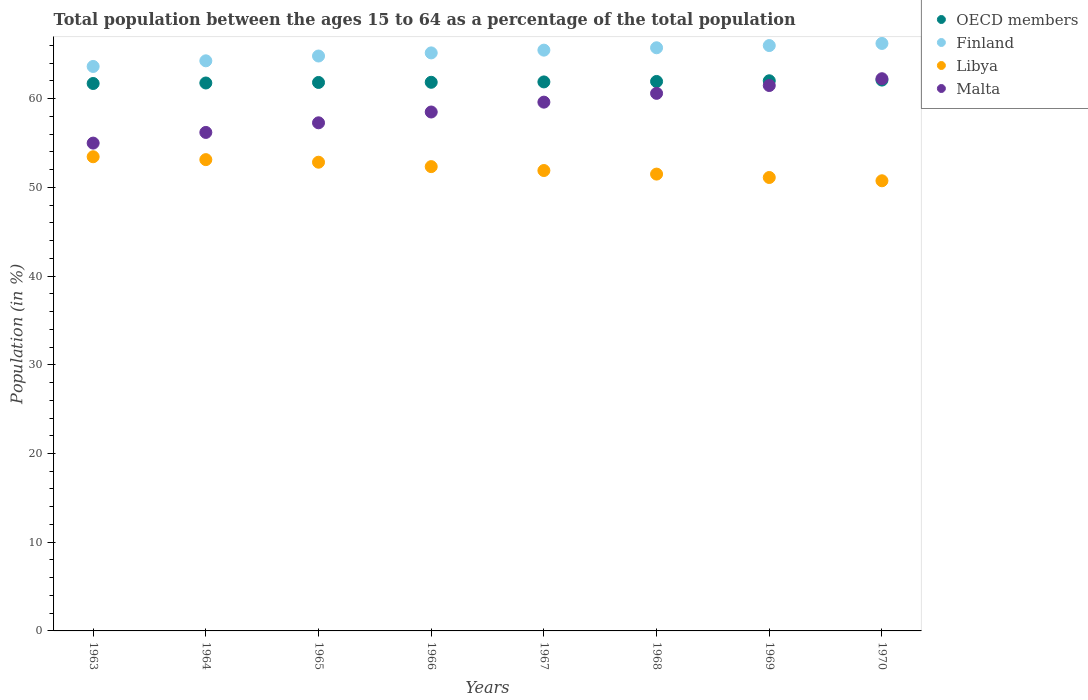Is the number of dotlines equal to the number of legend labels?
Offer a terse response. Yes. What is the percentage of the population ages 15 to 64 in Libya in 1968?
Keep it short and to the point. 51.5. Across all years, what is the maximum percentage of the population ages 15 to 64 in Finland?
Ensure brevity in your answer.  66.22. Across all years, what is the minimum percentage of the population ages 15 to 64 in Finland?
Provide a short and direct response. 63.63. In which year was the percentage of the population ages 15 to 64 in Libya minimum?
Make the answer very short. 1970. What is the total percentage of the population ages 15 to 64 in Libya in the graph?
Give a very brief answer. 417. What is the difference between the percentage of the population ages 15 to 64 in Libya in 1967 and that in 1970?
Keep it short and to the point. 1.16. What is the difference between the percentage of the population ages 15 to 64 in Libya in 1969 and the percentage of the population ages 15 to 64 in Finland in 1966?
Offer a very short reply. -14.05. What is the average percentage of the population ages 15 to 64 in OECD members per year?
Your answer should be compact. 61.88. In the year 1964, what is the difference between the percentage of the population ages 15 to 64 in Malta and percentage of the population ages 15 to 64 in Libya?
Your response must be concise. 3.07. In how many years, is the percentage of the population ages 15 to 64 in Finland greater than 38?
Provide a succinct answer. 8. What is the ratio of the percentage of the population ages 15 to 64 in Finland in 1964 to that in 1970?
Keep it short and to the point. 0.97. Is the difference between the percentage of the population ages 15 to 64 in Malta in 1963 and 1964 greater than the difference between the percentage of the population ages 15 to 64 in Libya in 1963 and 1964?
Give a very brief answer. No. What is the difference between the highest and the second highest percentage of the population ages 15 to 64 in Finland?
Ensure brevity in your answer.  0.24. What is the difference between the highest and the lowest percentage of the population ages 15 to 64 in Finland?
Give a very brief answer. 2.59. In how many years, is the percentage of the population ages 15 to 64 in Libya greater than the average percentage of the population ages 15 to 64 in Libya taken over all years?
Provide a short and direct response. 4. Is it the case that in every year, the sum of the percentage of the population ages 15 to 64 in OECD members and percentage of the population ages 15 to 64 in Libya  is greater than the sum of percentage of the population ages 15 to 64 in Malta and percentage of the population ages 15 to 64 in Finland?
Ensure brevity in your answer.  Yes. Does the percentage of the population ages 15 to 64 in Libya monotonically increase over the years?
Your answer should be compact. No. Is the percentage of the population ages 15 to 64 in Finland strictly greater than the percentage of the population ages 15 to 64 in Malta over the years?
Make the answer very short. Yes. How many dotlines are there?
Offer a terse response. 4. What is the difference between two consecutive major ticks on the Y-axis?
Ensure brevity in your answer.  10. Does the graph contain any zero values?
Ensure brevity in your answer.  No. Does the graph contain grids?
Provide a succinct answer. No. Where does the legend appear in the graph?
Offer a very short reply. Top right. How many legend labels are there?
Your answer should be very brief. 4. What is the title of the graph?
Your answer should be compact. Total population between the ages 15 to 64 as a percentage of the total population. What is the label or title of the X-axis?
Ensure brevity in your answer.  Years. What is the label or title of the Y-axis?
Ensure brevity in your answer.  Population (in %). What is the Population (in %) in OECD members in 1963?
Your response must be concise. 61.71. What is the Population (in %) in Finland in 1963?
Your answer should be compact. 63.63. What is the Population (in %) in Libya in 1963?
Keep it short and to the point. 53.45. What is the Population (in %) in Malta in 1963?
Offer a terse response. 54.99. What is the Population (in %) in OECD members in 1964?
Offer a terse response. 61.76. What is the Population (in %) of Finland in 1964?
Keep it short and to the point. 64.26. What is the Population (in %) of Libya in 1964?
Your answer should be compact. 53.13. What is the Population (in %) of Malta in 1964?
Offer a very short reply. 56.19. What is the Population (in %) of OECD members in 1965?
Your answer should be very brief. 61.83. What is the Population (in %) of Finland in 1965?
Your response must be concise. 64.8. What is the Population (in %) of Libya in 1965?
Give a very brief answer. 52.84. What is the Population (in %) of Malta in 1965?
Offer a very short reply. 57.28. What is the Population (in %) in OECD members in 1966?
Keep it short and to the point. 61.84. What is the Population (in %) of Finland in 1966?
Make the answer very short. 65.16. What is the Population (in %) in Libya in 1966?
Keep it short and to the point. 52.34. What is the Population (in %) of Malta in 1966?
Your answer should be compact. 58.49. What is the Population (in %) of OECD members in 1967?
Offer a terse response. 61.89. What is the Population (in %) in Finland in 1967?
Offer a very short reply. 65.47. What is the Population (in %) of Libya in 1967?
Make the answer very short. 51.9. What is the Population (in %) in Malta in 1967?
Make the answer very short. 59.6. What is the Population (in %) of OECD members in 1968?
Offer a very short reply. 61.94. What is the Population (in %) in Finland in 1968?
Offer a very short reply. 65.74. What is the Population (in %) in Libya in 1968?
Provide a short and direct response. 51.5. What is the Population (in %) in Malta in 1968?
Your response must be concise. 60.6. What is the Population (in %) in OECD members in 1969?
Provide a succinct answer. 62.01. What is the Population (in %) of Finland in 1969?
Give a very brief answer. 65.98. What is the Population (in %) of Libya in 1969?
Offer a terse response. 51.11. What is the Population (in %) in Malta in 1969?
Your answer should be compact. 61.48. What is the Population (in %) of OECD members in 1970?
Make the answer very short. 62.09. What is the Population (in %) of Finland in 1970?
Make the answer very short. 66.22. What is the Population (in %) of Libya in 1970?
Your response must be concise. 50.74. What is the Population (in %) of Malta in 1970?
Your answer should be very brief. 62.25. Across all years, what is the maximum Population (in %) in OECD members?
Ensure brevity in your answer.  62.09. Across all years, what is the maximum Population (in %) of Finland?
Your answer should be compact. 66.22. Across all years, what is the maximum Population (in %) of Libya?
Offer a terse response. 53.45. Across all years, what is the maximum Population (in %) of Malta?
Your response must be concise. 62.25. Across all years, what is the minimum Population (in %) in OECD members?
Offer a very short reply. 61.71. Across all years, what is the minimum Population (in %) in Finland?
Provide a short and direct response. 63.63. Across all years, what is the minimum Population (in %) of Libya?
Provide a succinct answer. 50.74. Across all years, what is the minimum Population (in %) in Malta?
Your answer should be very brief. 54.99. What is the total Population (in %) of OECD members in the graph?
Your answer should be compact. 495.07. What is the total Population (in %) of Finland in the graph?
Offer a very short reply. 521.26. What is the total Population (in %) of Libya in the graph?
Provide a succinct answer. 417. What is the total Population (in %) in Malta in the graph?
Ensure brevity in your answer.  470.88. What is the difference between the Population (in %) in OECD members in 1963 and that in 1964?
Offer a terse response. -0.06. What is the difference between the Population (in %) in Finland in 1963 and that in 1964?
Provide a succinct answer. -0.64. What is the difference between the Population (in %) in Libya in 1963 and that in 1964?
Your answer should be compact. 0.32. What is the difference between the Population (in %) of Malta in 1963 and that in 1964?
Offer a very short reply. -1.2. What is the difference between the Population (in %) of OECD members in 1963 and that in 1965?
Your answer should be compact. -0.12. What is the difference between the Population (in %) of Finland in 1963 and that in 1965?
Give a very brief answer. -1.18. What is the difference between the Population (in %) in Libya in 1963 and that in 1965?
Your answer should be compact. 0.61. What is the difference between the Population (in %) in Malta in 1963 and that in 1965?
Keep it short and to the point. -2.29. What is the difference between the Population (in %) in OECD members in 1963 and that in 1966?
Give a very brief answer. -0.14. What is the difference between the Population (in %) in Finland in 1963 and that in 1966?
Your answer should be compact. -1.53. What is the difference between the Population (in %) in Libya in 1963 and that in 1966?
Offer a terse response. 1.11. What is the difference between the Population (in %) of Malta in 1963 and that in 1966?
Offer a terse response. -3.51. What is the difference between the Population (in %) in OECD members in 1963 and that in 1967?
Your response must be concise. -0.18. What is the difference between the Population (in %) in Finland in 1963 and that in 1967?
Provide a short and direct response. -1.84. What is the difference between the Population (in %) in Libya in 1963 and that in 1967?
Give a very brief answer. 1.55. What is the difference between the Population (in %) of Malta in 1963 and that in 1967?
Provide a short and direct response. -4.62. What is the difference between the Population (in %) of OECD members in 1963 and that in 1968?
Give a very brief answer. -0.23. What is the difference between the Population (in %) in Finland in 1963 and that in 1968?
Make the answer very short. -2.11. What is the difference between the Population (in %) of Libya in 1963 and that in 1968?
Your response must be concise. 1.95. What is the difference between the Population (in %) of Malta in 1963 and that in 1968?
Make the answer very short. -5.61. What is the difference between the Population (in %) of OECD members in 1963 and that in 1969?
Make the answer very short. -0.31. What is the difference between the Population (in %) in Finland in 1963 and that in 1969?
Your response must be concise. -2.36. What is the difference between the Population (in %) in Libya in 1963 and that in 1969?
Your answer should be compact. 2.34. What is the difference between the Population (in %) in Malta in 1963 and that in 1969?
Keep it short and to the point. -6.49. What is the difference between the Population (in %) of OECD members in 1963 and that in 1970?
Your response must be concise. -0.39. What is the difference between the Population (in %) in Finland in 1963 and that in 1970?
Ensure brevity in your answer.  -2.59. What is the difference between the Population (in %) of Libya in 1963 and that in 1970?
Keep it short and to the point. 2.71. What is the difference between the Population (in %) of Malta in 1963 and that in 1970?
Provide a short and direct response. -7.26. What is the difference between the Population (in %) of OECD members in 1964 and that in 1965?
Ensure brevity in your answer.  -0.06. What is the difference between the Population (in %) of Finland in 1964 and that in 1965?
Keep it short and to the point. -0.54. What is the difference between the Population (in %) of Libya in 1964 and that in 1965?
Offer a terse response. 0.29. What is the difference between the Population (in %) in Malta in 1964 and that in 1965?
Offer a terse response. -1.08. What is the difference between the Population (in %) in OECD members in 1964 and that in 1966?
Your answer should be compact. -0.08. What is the difference between the Population (in %) of Finland in 1964 and that in 1966?
Offer a terse response. -0.89. What is the difference between the Population (in %) of Libya in 1964 and that in 1966?
Provide a short and direct response. 0.79. What is the difference between the Population (in %) of Malta in 1964 and that in 1966?
Offer a very short reply. -2.3. What is the difference between the Population (in %) in OECD members in 1964 and that in 1967?
Your response must be concise. -0.12. What is the difference between the Population (in %) of Finland in 1964 and that in 1967?
Make the answer very short. -1.2. What is the difference between the Population (in %) in Libya in 1964 and that in 1967?
Provide a succinct answer. 1.23. What is the difference between the Population (in %) of Malta in 1964 and that in 1967?
Make the answer very short. -3.41. What is the difference between the Population (in %) of OECD members in 1964 and that in 1968?
Offer a very short reply. -0.17. What is the difference between the Population (in %) in Finland in 1964 and that in 1968?
Offer a very short reply. -1.47. What is the difference between the Population (in %) in Libya in 1964 and that in 1968?
Offer a terse response. 1.63. What is the difference between the Population (in %) in Malta in 1964 and that in 1968?
Your answer should be very brief. -4.41. What is the difference between the Population (in %) in OECD members in 1964 and that in 1969?
Your answer should be compact. -0.25. What is the difference between the Population (in %) of Finland in 1964 and that in 1969?
Provide a short and direct response. -1.72. What is the difference between the Population (in %) in Libya in 1964 and that in 1969?
Provide a succinct answer. 2.01. What is the difference between the Population (in %) of Malta in 1964 and that in 1969?
Make the answer very short. -5.29. What is the difference between the Population (in %) of OECD members in 1964 and that in 1970?
Offer a very short reply. -0.33. What is the difference between the Population (in %) in Finland in 1964 and that in 1970?
Ensure brevity in your answer.  -1.96. What is the difference between the Population (in %) in Libya in 1964 and that in 1970?
Your answer should be very brief. 2.38. What is the difference between the Population (in %) in Malta in 1964 and that in 1970?
Make the answer very short. -6.05. What is the difference between the Population (in %) in OECD members in 1965 and that in 1966?
Provide a succinct answer. -0.02. What is the difference between the Population (in %) of Finland in 1965 and that in 1966?
Your answer should be very brief. -0.35. What is the difference between the Population (in %) in Libya in 1965 and that in 1966?
Provide a succinct answer. 0.5. What is the difference between the Population (in %) in Malta in 1965 and that in 1966?
Your answer should be compact. -1.22. What is the difference between the Population (in %) of OECD members in 1965 and that in 1967?
Keep it short and to the point. -0.06. What is the difference between the Population (in %) in Finland in 1965 and that in 1967?
Provide a short and direct response. -0.66. What is the difference between the Population (in %) in Libya in 1965 and that in 1967?
Ensure brevity in your answer.  0.94. What is the difference between the Population (in %) of Malta in 1965 and that in 1967?
Provide a short and direct response. -2.33. What is the difference between the Population (in %) of OECD members in 1965 and that in 1968?
Provide a short and direct response. -0.11. What is the difference between the Population (in %) in Finland in 1965 and that in 1968?
Ensure brevity in your answer.  -0.93. What is the difference between the Population (in %) in Libya in 1965 and that in 1968?
Keep it short and to the point. 1.34. What is the difference between the Population (in %) of Malta in 1965 and that in 1968?
Give a very brief answer. -3.32. What is the difference between the Population (in %) in OECD members in 1965 and that in 1969?
Provide a short and direct response. -0.19. What is the difference between the Population (in %) in Finland in 1965 and that in 1969?
Provide a short and direct response. -1.18. What is the difference between the Population (in %) in Libya in 1965 and that in 1969?
Provide a succinct answer. 1.72. What is the difference between the Population (in %) of Malta in 1965 and that in 1969?
Offer a very short reply. -4.2. What is the difference between the Population (in %) of OECD members in 1965 and that in 1970?
Keep it short and to the point. -0.27. What is the difference between the Population (in %) in Finland in 1965 and that in 1970?
Your answer should be very brief. -1.42. What is the difference between the Population (in %) in Libya in 1965 and that in 1970?
Offer a very short reply. 2.09. What is the difference between the Population (in %) in Malta in 1965 and that in 1970?
Provide a short and direct response. -4.97. What is the difference between the Population (in %) in OECD members in 1966 and that in 1967?
Your response must be concise. -0.04. What is the difference between the Population (in %) of Finland in 1966 and that in 1967?
Offer a terse response. -0.31. What is the difference between the Population (in %) of Libya in 1966 and that in 1967?
Offer a terse response. 0.44. What is the difference between the Population (in %) of Malta in 1966 and that in 1967?
Your answer should be compact. -1.11. What is the difference between the Population (in %) of OECD members in 1966 and that in 1968?
Your response must be concise. -0.09. What is the difference between the Population (in %) in Finland in 1966 and that in 1968?
Offer a very short reply. -0.58. What is the difference between the Population (in %) of Libya in 1966 and that in 1968?
Make the answer very short. 0.84. What is the difference between the Population (in %) of Malta in 1966 and that in 1968?
Offer a terse response. -2.1. What is the difference between the Population (in %) in OECD members in 1966 and that in 1969?
Your answer should be very brief. -0.17. What is the difference between the Population (in %) of Finland in 1966 and that in 1969?
Provide a succinct answer. -0.83. What is the difference between the Population (in %) in Libya in 1966 and that in 1969?
Give a very brief answer. 1.23. What is the difference between the Population (in %) of Malta in 1966 and that in 1969?
Ensure brevity in your answer.  -2.99. What is the difference between the Population (in %) in OECD members in 1966 and that in 1970?
Your answer should be compact. -0.25. What is the difference between the Population (in %) of Finland in 1966 and that in 1970?
Make the answer very short. -1.07. What is the difference between the Population (in %) of Libya in 1966 and that in 1970?
Offer a very short reply. 1.6. What is the difference between the Population (in %) of Malta in 1966 and that in 1970?
Your answer should be very brief. -3.75. What is the difference between the Population (in %) in OECD members in 1967 and that in 1968?
Keep it short and to the point. -0.05. What is the difference between the Population (in %) in Finland in 1967 and that in 1968?
Your answer should be very brief. -0.27. What is the difference between the Population (in %) in Libya in 1967 and that in 1968?
Ensure brevity in your answer.  0.4. What is the difference between the Population (in %) in Malta in 1967 and that in 1968?
Your answer should be very brief. -0.99. What is the difference between the Population (in %) in OECD members in 1967 and that in 1969?
Provide a succinct answer. -0.13. What is the difference between the Population (in %) in Finland in 1967 and that in 1969?
Ensure brevity in your answer.  -0.52. What is the difference between the Population (in %) in Libya in 1967 and that in 1969?
Provide a short and direct response. 0.79. What is the difference between the Population (in %) in Malta in 1967 and that in 1969?
Ensure brevity in your answer.  -1.88. What is the difference between the Population (in %) of OECD members in 1967 and that in 1970?
Make the answer very short. -0.21. What is the difference between the Population (in %) in Finland in 1967 and that in 1970?
Your response must be concise. -0.76. What is the difference between the Population (in %) of Libya in 1967 and that in 1970?
Keep it short and to the point. 1.16. What is the difference between the Population (in %) in Malta in 1967 and that in 1970?
Give a very brief answer. -2.64. What is the difference between the Population (in %) in OECD members in 1968 and that in 1969?
Provide a short and direct response. -0.08. What is the difference between the Population (in %) in Finland in 1968 and that in 1969?
Keep it short and to the point. -0.25. What is the difference between the Population (in %) of Libya in 1968 and that in 1969?
Keep it short and to the point. 0.38. What is the difference between the Population (in %) of Malta in 1968 and that in 1969?
Ensure brevity in your answer.  -0.88. What is the difference between the Population (in %) in OECD members in 1968 and that in 1970?
Offer a very short reply. -0.16. What is the difference between the Population (in %) of Finland in 1968 and that in 1970?
Provide a short and direct response. -0.49. What is the difference between the Population (in %) in Libya in 1968 and that in 1970?
Offer a very short reply. 0.75. What is the difference between the Population (in %) in Malta in 1968 and that in 1970?
Ensure brevity in your answer.  -1.65. What is the difference between the Population (in %) in OECD members in 1969 and that in 1970?
Provide a short and direct response. -0.08. What is the difference between the Population (in %) in Finland in 1969 and that in 1970?
Your response must be concise. -0.24. What is the difference between the Population (in %) in Libya in 1969 and that in 1970?
Offer a terse response. 0.37. What is the difference between the Population (in %) in Malta in 1969 and that in 1970?
Your response must be concise. -0.77. What is the difference between the Population (in %) in OECD members in 1963 and the Population (in %) in Finland in 1964?
Your response must be concise. -2.56. What is the difference between the Population (in %) of OECD members in 1963 and the Population (in %) of Libya in 1964?
Provide a succinct answer. 8.58. What is the difference between the Population (in %) of OECD members in 1963 and the Population (in %) of Malta in 1964?
Provide a succinct answer. 5.52. What is the difference between the Population (in %) of Finland in 1963 and the Population (in %) of Libya in 1964?
Provide a succinct answer. 10.5. What is the difference between the Population (in %) in Finland in 1963 and the Population (in %) in Malta in 1964?
Provide a short and direct response. 7.44. What is the difference between the Population (in %) in Libya in 1963 and the Population (in %) in Malta in 1964?
Provide a short and direct response. -2.74. What is the difference between the Population (in %) in OECD members in 1963 and the Population (in %) in Finland in 1965?
Offer a very short reply. -3.1. What is the difference between the Population (in %) of OECD members in 1963 and the Population (in %) of Libya in 1965?
Your answer should be compact. 8.87. What is the difference between the Population (in %) in OECD members in 1963 and the Population (in %) in Malta in 1965?
Give a very brief answer. 4.43. What is the difference between the Population (in %) of Finland in 1963 and the Population (in %) of Libya in 1965?
Your answer should be compact. 10.79. What is the difference between the Population (in %) in Finland in 1963 and the Population (in %) in Malta in 1965?
Keep it short and to the point. 6.35. What is the difference between the Population (in %) in Libya in 1963 and the Population (in %) in Malta in 1965?
Ensure brevity in your answer.  -3.83. What is the difference between the Population (in %) of OECD members in 1963 and the Population (in %) of Finland in 1966?
Keep it short and to the point. -3.45. What is the difference between the Population (in %) of OECD members in 1963 and the Population (in %) of Libya in 1966?
Give a very brief answer. 9.37. What is the difference between the Population (in %) in OECD members in 1963 and the Population (in %) in Malta in 1966?
Your answer should be very brief. 3.21. What is the difference between the Population (in %) of Finland in 1963 and the Population (in %) of Libya in 1966?
Offer a terse response. 11.29. What is the difference between the Population (in %) of Finland in 1963 and the Population (in %) of Malta in 1966?
Offer a very short reply. 5.13. What is the difference between the Population (in %) in Libya in 1963 and the Population (in %) in Malta in 1966?
Make the answer very short. -5.04. What is the difference between the Population (in %) of OECD members in 1963 and the Population (in %) of Finland in 1967?
Your answer should be compact. -3.76. What is the difference between the Population (in %) in OECD members in 1963 and the Population (in %) in Libya in 1967?
Provide a short and direct response. 9.81. What is the difference between the Population (in %) in OECD members in 1963 and the Population (in %) in Malta in 1967?
Your answer should be compact. 2.1. What is the difference between the Population (in %) in Finland in 1963 and the Population (in %) in Libya in 1967?
Offer a very short reply. 11.73. What is the difference between the Population (in %) in Finland in 1963 and the Population (in %) in Malta in 1967?
Make the answer very short. 4.02. What is the difference between the Population (in %) of Libya in 1963 and the Population (in %) of Malta in 1967?
Provide a short and direct response. -6.15. What is the difference between the Population (in %) in OECD members in 1963 and the Population (in %) in Finland in 1968?
Your answer should be very brief. -4.03. What is the difference between the Population (in %) in OECD members in 1963 and the Population (in %) in Libya in 1968?
Your response must be concise. 10.21. What is the difference between the Population (in %) in OECD members in 1963 and the Population (in %) in Malta in 1968?
Offer a very short reply. 1.11. What is the difference between the Population (in %) of Finland in 1963 and the Population (in %) of Libya in 1968?
Your answer should be compact. 12.13. What is the difference between the Population (in %) in Finland in 1963 and the Population (in %) in Malta in 1968?
Provide a succinct answer. 3.03. What is the difference between the Population (in %) in Libya in 1963 and the Population (in %) in Malta in 1968?
Your answer should be very brief. -7.15. What is the difference between the Population (in %) in OECD members in 1963 and the Population (in %) in Finland in 1969?
Keep it short and to the point. -4.28. What is the difference between the Population (in %) in OECD members in 1963 and the Population (in %) in Libya in 1969?
Your answer should be compact. 10.6. What is the difference between the Population (in %) in OECD members in 1963 and the Population (in %) in Malta in 1969?
Give a very brief answer. 0.23. What is the difference between the Population (in %) of Finland in 1963 and the Population (in %) of Libya in 1969?
Keep it short and to the point. 12.52. What is the difference between the Population (in %) of Finland in 1963 and the Population (in %) of Malta in 1969?
Make the answer very short. 2.15. What is the difference between the Population (in %) in Libya in 1963 and the Population (in %) in Malta in 1969?
Offer a terse response. -8.03. What is the difference between the Population (in %) of OECD members in 1963 and the Population (in %) of Finland in 1970?
Your answer should be compact. -4.51. What is the difference between the Population (in %) of OECD members in 1963 and the Population (in %) of Libya in 1970?
Give a very brief answer. 10.97. What is the difference between the Population (in %) in OECD members in 1963 and the Population (in %) in Malta in 1970?
Your response must be concise. -0.54. What is the difference between the Population (in %) in Finland in 1963 and the Population (in %) in Libya in 1970?
Your response must be concise. 12.89. What is the difference between the Population (in %) of Finland in 1963 and the Population (in %) of Malta in 1970?
Give a very brief answer. 1.38. What is the difference between the Population (in %) in Libya in 1963 and the Population (in %) in Malta in 1970?
Your answer should be very brief. -8.8. What is the difference between the Population (in %) of OECD members in 1964 and the Population (in %) of Finland in 1965?
Your answer should be very brief. -3.04. What is the difference between the Population (in %) in OECD members in 1964 and the Population (in %) in Libya in 1965?
Make the answer very short. 8.93. What is the difference between the Population (in %) of OECD members in 1964 and the Population (in %) of Malta in 1965?
Provide a succinct answer. 4.49. What is the difference between the Population (in %) of Finland in 1964 and the Population (in %) of Libya in 1965?
Keep it short and to the point. 11.43. What is the difference between the Population (in %) in Finland in 1964 and the Population (in %) in Malta in 1965?
Your answer should be compact. 6.99. What is the difference between the Population (in %) in Libya in 1964 and the Population (in %) in Malta in 1965?
Your response must be concise. -4.15. What is the difference between the Population (in %) of OECD members in 1964 and the Population (in %) of Finland in 1966?
Your answer should be very brief. -3.39. What is the difference between the Population (in %) of OECD members in 1964 and the Population (in %) of Libya in 1966?
Provide a short and direct response. 9.43. What is the difference between the Population (in %) of OECD members in 1964 and the Population (in %) of Malta in 1966?
Your answer should be very brief. 3.27. What is the difference between the Population (in %) in Finland in 1964 and the Population (in %) in Libya in 1966?
Give a very brief answer. 11.93. What is the difference between the Population (in %) of Finland in 1964 and the Population (in %) of Malta in 1966?
Your response must be concise. 5.77. What is the difference between the Population (in %) in Libya in 1964 and the Population (in %) in Malta in 1966?
Provide a short and direct response. -5.37. What is the difference between the Population (in %) of OECD members in 1964 and the Population (in %) of Finland in 1967?
Your response must be concise. -3.7. What is the difference between the Population (in %) of OECD members in 1964 and the Population (in %) of Libya in 1967?
Provide a succinct answer. 9.87. What is the difference between the Population (in %) in OECD members in 1964 and the Population (in %) in Malta in 1967?
Your answer should be very brief. 2.16. What is the difference between the Population (in %) in Finland in 1964 and the Population (in %) in Libya in 1967?
Offer a very short reply. 12.37. What is the difference between the Population (in %) of Finland in 1964 and the Population (in %) of Malta in 1967?
Make the answer very short. 4.66. What is the difference between the Population (in %) of Libya in 1964 and the Population (in %) of Malta in 1967?
Give a very brief answer. -6.48. What is the difference between the Population (in %) of OECD members in 1964 and the Population (in %) of Finland in 1968?
Keep it short and to the point. -3.97. What is the difference between the Population (in %) in OECD members in 1964 and the Population (in %) in Libya in 1968?
Ensure brevity in your answer.  10.27. What is the difference between the Population (in %) in OECD members in 1964 and the Population (in %) in Malta in 1968?
Ensure brevity in your answer.  1.17. What is the difference between the Population (in %) in Finland in 1964 and the Population (in %) in Libya in 1968?
Make the answer very short. 12.77. What is the difference between the Population (in %) of Finland in 1964 and the Population (in %) of Malta in 1968?
Provide a short and direct response. 3.67. What is the difference between the Population (in %) of Libya in 1964 and the Population (in %) of Malta in 1968?
Offer a terse response. -7.47. What is the difference between the Population (in %) in OECD members in 1964 and the Population (in %) in Finland in 1969?
Keep it short and to the point. -4.22. What is the difference between the Population (in %) of OECD members in 1964 and the Population (in %) of Libya in 1969?
Give a very brief answer. 10.65. What is the difference between the Population (in %) of OECD members in 1964 and the Population (in %) of Malta in 1969?
Give a very brief answer. 0.28. What is the difference between the Population (in %) in Finland in 1964 and the Population (in %) in Libya in 1969?
Offer a very short reply. 13.15. What is the difference between the Population (in %) in Finland in 1964 and the Population (in %) in Malta in 1969?
Offer a very short reply. 2.78. What is the difference between the Population (in %) in Libya in 1964 and the Population (in %) in Malta in 1969?
Provide a succinct answer. -8.35. What is the difference between the Population (in %) of OECD members in 1964 and the Population (in %) of Finland in 1970?
Provide a short and direct response. -4.46. What is the difference between the Population (in %) of OECD members in 1964 and the Population (in %) of Libya in 1970?
Make the answer very short. 11.02. What is the difference between the Population (in %) of OECD members in 1964 and the Population (in %) of Malta in 1970?
Make the answer very short. -0.48. What is the difference between the Population (in %) in Finland in 1964 and the Population (in %) in Libya in 1970?
Keep it short and to the point. 13.52. What is the difference between the Population (in %) of Finland in 1964 and the Population (in %) of Malta in 1970?
Your answer should be very brief. 2.02. What is the difference between the Population (in %) in Libya in 1964 and the Population (in %) in Malta in 1970?
Ensure brevity in your answer.  -9.12. What is the difference between the Population (in %) in OECD members in 1965 and the Population (in %) in Finland in 1966?
Ensure brevity in your answer.  -3.33. What is the difference between the Population (in %) in OECD members in 1965 and the Population (in %) in Libya in 1966?
Your response must be concise. 9.49. What is the difference between the Population (in %) in OECD members in 1965 and the Population (in %) in Malta in 1966?
Provide a short and direct response. 3.33. What is the difference between the Population (in %) of Finland in 1965 and the Population (in %) of Libya in 1966?
Provide a short and direct response. 12.47. What is the difference between the Population (in %) in Finland in 1965 and the Population (in %) in Malta in 1966?
Keep it short and to the point. 6.31. What is the difference between the Population (in %) in Libya in 1965 and the Population (in %) in Malta in 1966?
Your answer should be compact. -5.66. What is the difference between the Population (in %) of OECD members in 1965 and the Population (in %) of Finland in 1967?
Your response must be concise. -3.64. What is the difference between the Population (in %) of OECD members in 1965 and the Population (in %) of Libya in 1967?
Make the answer very short. 9.93. What is the difference between the Population (in %) in OECD members in 1965 and the Population (in %) in Malta in 1967?
Ensure brevity in your answer.  2.22. What is the difference between the Population (in %) of Finland in 1965 and the Population (in %) of Libya in 1967?
Your answer should be very brief. 12.91. What is the difference between the Population (in %) in Finland in 1965 and the Population (in %) in Malta in 1967?
Your response must be concise. 5.2. What is the difference between the Population (in %) of Libya in 1965 and the Population (in %) of Malta in 1967?
Keep it short and to the point. -6.77. What is the difference between the Population (in %) of OECD members in 1965 and the Population (in %) of Finland in 1968?
Your answer should be very brief. -3.91. What is the difference between the Population (in %) of OECD members in 1965 and the Population (in %) of Libya in 1968?
Your answer should be very brief. 10.33. What is the difference between the Population (in %) in OECD members in 1965 and the Population (in %) in Malta in 1968?
Offer a very short reply. 1.23. What is the difference between the Population (in %) of Finland in 1965 and the Population (in %) of Libya in 1968?
Provide a short and direct response. 13.31. What is the difference between the Population (in %) in Finland in 1965 and the Population (in %) in Malta in 1968?
Provide a short and direct response. 4.21. What is the difference between the Population (in %) in Libya in 1965 and the Population (in %) in Malta in 1968?
Give a very brief answer. -7.76. What is the difference between the Population (in %) of OECD members in 1965 and the Population (in %) of Finland in 1969?
Provide a succinct answer. -4.16. What is the difference between the Population (in %) in OECD members in 1965 and the Population (in %) in Libya in 1969?
Provide a short and direct response. 10.71. What is the difference between the Population (in %) of OECD members in 1965 and the Population (in %) of Malta in 1969?
Your answer should be compact. 0.34. What is the difference between the Population (in %) of Finland in 1965 and the Population (in %) of Libya in 1969?
Provide a succinct answer. 13.69. What is the difference between the Population (in %) in Finland in 1965 and the Population (in %) in Malta in 1969?
Give a very brief answer. 3.32. What is the difference between the Population (in %) of Libya in 1965 and the Population (in %) of Malta in 1969?
Give a very brief answer. -8.64. What is the difference between the Population (in %) in OECD members in 1965 and the Population (in %) in Finland in 1970?
Provide a short and direct response. -4.4. What is the difference between the Population (in %) in OECD members in 1965 and the Population (in %) in Libya in 1970?
Your answer should be compact. 11.08. What is the difference between the Population (in %) in OECD members in 1965 and the Population (in %) in Malta in 1970?
Make the answer very short. -0.42. What is the difference between the Population (in %) of Finland in 1965 and the Population (in %) of Libya in 1970?
Your answer should be compact. 14.06. What is the difference between the Population (in %) of Finland in 1965 and the Population (in %) of Malta in 1970?
Provide a succinct answer. 2.56. What is the difference between the Population (in %) of Libya in 1965 and the Population (in %) of Malta in 1970?
Your answer should be very brief. -9.41. What is the difference between the Population (in %) of OECD members in 1966 and the Population (in %) of Finland in 1967?
Offer a terse response. -3.62. What is the difference between the Population (in %) of OECD members in 1966 and the Population (in %) of Libya in 1967?
Offer a terse response. 9.95. What is the difference between the Population (in %) in OECD members in 1966 and the Population (in %) in Malta in 1967?
Make the answer very short. 2.24. What is the difference between the Population (in %) of Finland in 1966 and the Population (in %) of Libya in 1967?
Offer a very short reply. 13.26. What is the difference between the Population (in %) of Finland in 1966 and the Population (in %) of Malta in 1967?
Provide a succinct answer. 5.55. What is the difference between the Population (in %) of Libya in 1966 and the Population (in %) of Malta in 1967?
Your response must be concise. -7.27. What is the difference between the Population (in %) in OECD members in 1966 and the Population (in %) in Finland in 1968?
Keep it short and to the point. -3.89. What is the difference between the Population (in %) in OECD members in 1966 and the Population (in %) in Libya in 1968?
Your response must be concise. 10.35. What is the difference between the Population (in %) of OECD members in 1966 and the Population (in %) of Malta in 1968?
Make the answer very short. 1.25. What is the difference between the Population (in %) of Finland in 1966 and the Population (in %) of Libya in 1968?
Give a very brief answer. 13.66. What is the difference between the Population (in %) in Finland in 1966 and the Population (in %) in Malta in 1968?
Your answer should be compact. 4.56. What is the difference between the Population (in %) in Libya in 1966 and the Population (in %) in Malta in 1968?
Offer a terse response. -8.26. What is the difference between the Population (in %) in OECD members in 1966 and the Population (in %) in Finland in 1969?
Your answer should be compact. -4.14. What is the difference between the Population (in %) in OECD members in 1966 and the Population (in %) in Libya in 1969?
Provide a short and direct response. 10.73. What is the difference between the Population (in %) of OECD members in 1966 and the Population (in %) of Malta in 1969?
Keep it short and to the point. 0.36. What is the difference between the Population (in %) in Finland in 1966 and the Population (in %) in Libya in 1969?
Give a very brief answer. 14.05. What is the difference between the Population (in %) in Finland in 1966 and the Population (in %) in Malta in 1969?
Give a very brief answer. 3.68. What is the difference between the Population (in %) in Libya in 1966 and the Population (in %) in Malta in 1969?
Offer a terse response. -9.14. What is the difference between the Population (in %) of OECD members in 1966 and the Population (in %) of Finland in 1970?
Provide a succinct answer. -4.38. What is the difference between the Population (in %) of OECD members in 1966 and the Population (in %) of Libya in 1970?
Make the answer very short. 11.1. What is the difference between the Population (in %) of OECD members in 1966 and the Population (in %) of Malta in 1970?
Ensure brevity in your answer.  -0.4. What is the difference between the Population (in %) of Finland in 1966 and the Population (in %) of Libya in 1970?
Ensure brevity in your answer.  14.41. What is the difference between the Population (in %) in Finland in 1966 and the Population (in %) in Malta in 1970?
Keep it short and to the point. 2.91. What is the difference between the Population (in %) in Libya in 1966 and the Population (in %) in Malta in 1970?
Ensure brevity in your answer.  -9.91. What is the difference between the Population (in %) in OECD members in 1967 and the Population (in %) in Finland in 1968?
Offer a terse response. -3.85. What is the difference between the Population (in %) in OECD members in 1967 and the Population (in %) in Libya in 1968?
Keep it short and to the point. 10.39. What is the difference between the Population (in %) of OECD members in 1967 and the Population (in %) of Malta in 1968?
Keep it short and to the point. 1.29. What is the difference between the Population (in %) of Finland in 1967 and the Population (in %) of Libya in 1968?
Offer a terse response. 13.97. What is the difference between the Population (in %) of Finland in 1967 and the Population (in %) of Malta in 1968?
Keep it short and to the point. 4.87. What is the difference between the Population (in %) of Libya in 1967 and the Population (in %) of Malta in 1968?
Ensure brevity in your answer.  -8.7. What is the difference between the Population (in %) in OECD members in 1967 and the Population (in %) in Finland in 1969?
Ensure brevity in your answer.  -4.1. What is the difference between the Population (in %) in OECD members in 1967 and the Population (in %) in Libya in 1969?
Your response must be concise. 10.77. What is the difference between the Population (in %) in OECD members in 1967 and the Population (in %) in Malta in 1969?
Your answer should be compact. 0.4. What is the difference between the Population (in %) of Finland in 1967 and the Population (in %) of Libya in 1969?
Give a very brief answer. 14.36. What is the difference between the Population (in %) in Finland in 1967 and the Population (in %) in Malta in 1969?
Keep it short and to the point. 3.99. What is the difference between the Population (in %) of Libya in 1967 and the Population (in %) of Malta in 1969?
Give a very brief answer. -9.58. What is the difference between the Population (in %) of OECD members in 1967 and the Population (in %) of Finland in 1970?
Your response must be concise. -4.34. What is the difference between the Population (in %) in OECD members in 1967 and the Population (in %) in Libya in 1970?
Ensure brevity in your answer.  11.14. What is the difference between the Population (in %) in OECD members in 1967 and the Population (in %) in Malta in 1970?
Your answer should be very brief. -0.36. What is the difference between the Population (in %) in Finland in 1967 and the Population (in %) in Libya in 1970?
Your response must be concise. 14.72. What is the difference between the Population (in %) in Finland in 1967 and the Population (in %) in Malta in 1970?
Give a very brief answer. 3.22. What is the difference between the Population (in %) in Libya in 1967 and the Population (in %) in Malta in 1970?
Your answer should be very brief. -10.35. What is the difference between the Population (in %) of OECD members in 1968 and the Population (in %) of Finland in 1969?
Your response must be concise. -4.05. What is the difference between the Population (in %) of OECD members in 1968 and the Population (in %) of Libya in 1969?
Keep it short and to the point. 10.83. What is the difference between the Population (in %) of OECD members in 1968 and the Population (in %) of Malta in 1969?
Your answer should be very brief. 0.46. What is the difference between the Population (in %) of Finland in 1968 and the Population (in %) of Libya in 1969?
Provide a succinct answer. 14.62. What is the difference between the Population (in %) in Finland in 1968 and the Population (in %) in Malta in 1969?
Give a very brief answer. 4.25. What is the difference between the Population (in %) of Libya in 1968 and the Population (in %) of Malta in 1969?
Offer a very short reply. -9.99. What is the difference between the Population (in %) in OECD members in 1968 and the Population (in %) in Finland in 1970?
Your answer should be very brief. -4.29. What is the difference between the Population (in %) of OECD members in 1968 and the Population (in %) of Libya in 1970?
Keep it short and to the point. 11.2. What is the difference between the Population (in %) of OECD members in 1968 and the Population (in %) of Malta in 1970?
Provide a succinct answer. -0.31. What is the difference between the Population (in %) in Finland in 1968 and the Population (in %) in Libya in 1970?
Offer a very short reply. 14.99. What is the difference between the Population (in %) of Finland in 1968 and the Population (in %) of Malta in 1970?
Keep it short and to the point. 3.49. What is the difference between the Population (in %) of Libya in 1968 and the Population (in %) of Malta in 1970?
Offer a very short reply. -10.75. What is the difference between the Population (in %) of OECD members in 1969 and the Population (in %) of Finland in 1970?
Your response must be concise. -4.21. What is the difference between the Population (in %) in OECD members in 1969 and the Population (in %) in Libya in 1970?
Your answer should be very brief. 11.27. What is the difference between the Population (in %) in OECD members in 1969 and the Population (in %) in Malta in 1970?
Your response must be concise. -0.23. What is the difference between the Population (in %) of Finland in 1969 and the Population (in %) of Libya in 1970?
Offer a very short reply. 15.24. What is the difference between the Population (in %) in Finland in 1969 and the Population (in %) in Malta in 1970?
Give a very brief answer. 3.74. What is the difference between the Population (in %) in Libya in 1969 and the Population (in %) in Malta in 1970?
Your answer should be very brief. -11.13. What is the average Population (in %) in OECD members per year?
Your answer should be compact. 61.88. What is the average Population (in %) in Finland per year?
Your answer should be very brief. 65.16. What is the average Population (in %) in Libya per year?
Provide a succinct answer. 52.12. What is the average Population (in %) of Malta per year?
Your answer should be compact. 58.86. In the year 1963, what is the difference between the Population (in %) in OECD members and Population (in %) in Finland?
Your answer should be compact. -1.92. In the year 1963, what is the difference between the Population (in %) of OECD members and Population (in %) of Libya?
Your answer should be compact. 8.26. In the year 1963, what is the difference between the Population (in %) of OECD members and Population (in %) of Malta?
Offer a terse response. 6.72. In the year 1963, what is the difference between the Population (in %) of Finland and Population (in %) of Libya?
Provide a short and direct response. 10.18. In the year 1963, what is the difference between the Population (in %) of Finland and Population (in %) of Malta?
Offer a very short reply. 8.64. In the year 1963, what is the difference between the Population (in %) of Libya and Population (in %) of Malta?
Your answer should be very brief. -1.54. In the year 1964, what is the difference between the Population (in %) of OECD members and Population (in %) of Finland?
Ensure brevity in your answer.  -2.5. In the year 1964, what is the difference between the Population (in %) of OECD members and Population (in %) of Libya?
Offer a terse response. 8.64. In the year 1964, what is the difference between the Population (in %) of OECD members and Population (in %) of Malta?
Give a very brief answer. 5.57. In the year 1964, what is the difference between the Population (in %) in Finland and Population (in %) in Libya?
Provide a succinct answer. 11.14. In the year 1964, what is the difference between the Population (in %) of Finland and Population (in %) of Malta?
Your response must be concise. 8.07. In the year 1964, what is the difference between the Population (in %) of Libya and Population (in %) of Malta?
Ensure brevity in your answer.  -3.07. In the year 1965, what is the difference between the Population (in %) of OECD members and Population (in %) of Finland?
Your answer should be very brief. -2.98. In the year 1965, what is the difference between the Population (in %) of OECD members and Population (in %) of Libya?
Your answer should be very brief. 8.99. In the year 1965, what is the difference between the Population (in %) of OECD members and Population (in %) of Malta?
Keep it short and to the point. 4.55. In the year 1965, what is the difference between the Population (in %) in Finland and Population (in %) in Libya?
Keep it short and to the point. 11.97. In the year 1965, what is the difference between the Population (in %) in Finland and Population (in %) in Malta?
Provide a short and direct response. 7.53. In the year 1965, what is the difference between the Population (in %) in Libya and Population (in %) in Malta?
Provide a succinct answer. -4.44. In the year 1966, what is the difference between the Population (in %) of OECD members and Population (in %) of Finland?
Provide a succinct answer. -3.31. In the year 1966, what is the difference between the Population (in %) of OECD members and Population (in %) of Libya?
Ensure brevity in your answer.  9.51. In the year 1966, what is the difference between the Population (in %) in OECD members and Population (in %) in Malta?
Offer a terse response. 3.35. In the year 1966, what is the difference between the Population (in %) in Finland and Population (in %) in Libya?
Ensure brevity in your answer.  12.82. In the year 1966, what is the difference between the Population (in %) of Finland and Population (in %) of Malta?
Your response must be concise. 6.66. In the year 1966, what is the difference between the Population (in %) in Libya and Population (in %) in Malta?
Provide a succinct answer. -6.16. In the year 1967, what is the difference between the Population (in %) of OECD members and Population (in %) of Finland?
Keep it short and to the point. -3.58. In the year 1967, what is the difference between the Population (in %) in OECD members and Population (in %) in Libya?
Your answer should be very brief. 9.99. In the year 1967, what is the difference between the Population (in %) in OECD members and Population (in %) in Malta?
Keep it short and to the point. 2.28. In the year 1967, what is the difference between the Population (in %) in Finland and Population (in %) in Libya?
Your answer should be very brief. 13.57. In the year 1967, what is the difference between the Population (in %) of Finland and Population (in %) of Malta?
Offer a very short reply. 5.86. In the year 1967, what is the difference between the Population (in %) in Libya and Population (in %) in Malta?
Offer a very short reply. -7.71. In the year 1968, what is the difference between the Population (in %) in OECD members and Population (in %) in Finland?
Provide a short and direct response. -3.8. In the year 1968, what is the difference between the Population (in %) in OECD members and Population (in %) in Libya?
Keep it short and to the point. 10.44. In the year 1968, what is the difference between the Population (in %) of OECD members and Population (in %) of Malta?
Keep it short and to the point. 1.34. In the year 1968, what is the difference between the Population (in %) in Finland and Population (in %) in Libya?
Offer a terse response. 14.24. In the year 1968, what is the difference between the Population (in %) in Finland and Population (in %) in Malta?
Make the answer very short. 5.14. In the year 1968, what is the difference between the Population (in %) in Libya and Population (in %) in Malta?
Ensure brevity in your answer.  -9.1. In the year 1969, what is the difference between the Population (in %) of OECD members and Population (in %) of Finland?
Offer a very short reply. -3.97. In the year 1969, what is the difference between the Population (in %) in OECD members and Population (in %) in Libya?
Provide a short and direct response. 10.9. In the year 1969, what is the difference between the Population (in %) in OECD members and Population (in %) in Malta?
Keep it short and to the point. 0.53. In the year 1969, what is the difference between the Population (in %) in Finland and Population (in %) in Libya?
Your answer should be compact. 14.87. In the year 1969, what is the difference between the Population (in %) in Finland and Population (in %) in Malta?
Provide a succinct answer. 4.5. In the year 1969, what is the difference between the Population (in %) in Libya and Population (in %) in Malta?
Offer a terse response. -10.37. In the year 1970, what is the difference between the Population (in %) in OECD members and Population (in %) in Finland?
Keep it short and to the point. -4.13. In the year 1970, what is the difference between the Population (in %) of OECD members and Population (in %) of Libya?
Make the answer very short. 11.35. In the year 1970, what is the difference between the Population (in %) in OECD members and Population (in %) in Malta?
Provide a short and direct response. -0.15. In the year 1970, what is the difference between the Population (in %) in Finland and Population (in %) in Libya?
Your answer should be very brief. 15.48. In the year 1970, what is the difference between the Population (in %) in Finland and Population (in %) in Malta?
Offer a very short reply. 3.98. In the year 1970, what is the difference between the Population (in %) in Libya and Population (in %) in Malta?
Provide a succinct answer. -11.5. What is the ratio of the Population (in %) in OECD members in 1963 to that in 1964?
Provide a short and direct response. 1. What is the ratio of the Population (in %) in Finland in 1963 to that in 1964?
Your answer should be very brief. 0.99. What is the ratio of the Population (in %) in Malta in 1963 to that in 1964?
Your answer should be very brief. 0.98. What is the ratio of the Population (in %) of Finland in 1963 to that in 1965?
Ensure brevity in your answer.  0.98. What is the ratio of the Population (in %) of Libya in 1963 to that in 1965?
Keep it short and to the point. 1.01. What is the ratio of the Population (in %) in Malta in 1963 to that in 1965?
Your answer should be compact. 0.96. What is the ratio of the Population (in %) of OECD members in 1963 to that in 1966?
Ensure brevity in your answer.  1. What is the ratio of the Population (in %) in Finland in 1963 to that in 1966?
Offer a very short reply. 0.98. What is the ratio of the Population (in %) of Libya in 1963 to that in 1966?
Your answer should be compact. 1.02. What is the ratio of the Population (in %) of Malta in 1963 to that in 1966?
Offer a terse response. 0.94. What is the ratio of the Population (in %) in OECD members in 1963 to that in 1967?
Make the answer very short. 1. What is the ratio of the Population (in %) of Finland in 1963 to that in 1967?
Give a very brief answer. 0.97. What is the ratio of the Population (in %) in Libya in 1963 to that in 1967?
Your answer should be compact. 1.03. What is the ratio of the Population (in %) in Malta in 1963 to that in 1967?
Ensure brevity in your answer.  0.92. What is the ratio of the Population (in %) in Finland in 1963 to that in 1968?
Your answer should be compact. 0.97. What is the ratio of the Population (in %) in Libya in 1963 to that in 1968?
Provide a succinct answer. 1.04. What is the ratio of the Population (in %) in Malta in 1963 to that in 1968?
Give a very brief answer. 0.91. What is the ratio of the Population (in %) of Finland in 1963 to that in 1969?
Your response must be concise. 0.96. What is the ratio of the Population (in %) of Libya in 1963 to that in 1969?
Your answer should be compact. 1.05. What is the ratio of the Population (in %) in Malta in 1963 to that in 1969?
Offer a very short reply. 0.89. What is the ratio of the Population (in %) of Finland in 1963 to that in 1970?
Provide a short and direct response. 0.96. What is the ratio of the Population (in %) of Libya in 1963 to that in 1970?
Give a very brief answer. 1.05. What is the ratio of the Population (in %) of Malta in 1963 to that in 1970?
Provide a succinct answer. 0.88. What is the ratio of the Population (in %) of Finland in 1964 to that in 1965?
Make the answer very short. 0.99. What is the ratio of the Population (in %) in Malta in 1964 to that in 1965?
Keep it short and to the point. 0.98. What is the ratio of the Population (in %) in OECD members in 1964 to that in 1966?
Your response must be concise. 1. What is the ratio of the Population (in %) of Finland in 1964 to that in 1966?
Provide a succinct answer. 0.99. What is the ratio of the Population (in %) of Libya in 1964 to that in 1966?
Keep it short and to the point. 1.02. What is the ratio of the Population (in %) in Malta in 1964 to that in 1966?
Keep it short and to the point. 0.96. What is the ratio of the Population (in %) of OECD members in 1964 to that in 1967?
Offer a very short reply. 1. What is the ratio of the Population (in %) in Finland in 1964 to that in 1967?
Offer a terse response. 0.98. What is the ratio of the Population (in %) in Libya in 1964 to that in 1967?
Ensure brevity in your answer.  1.02. What is the ratio of the Population (in %) of Malta in 1964 to that in 1967?
Offer a very short reply. 0.94. What is the ratio of the Population (in %) of Finland in 1964 to that in 1968?
Offer a very short reply. 0.98. What is the ratio of the Population (in %) of Libya in 1964 to that in 1968?
Offer a very short reply. 1.03. What is the ratio of the Population (in %) in Malta in 1964 to that in 1968?
Provide a short and direct response. 0.93. What is the ratio of the Population (in %) of Finland in 1964 to that in 1969?
Your response must be concise. 0.97. What is the ratio of the Population (in %) in Libya in 1964 to that in 1969?
Provide a short and direct response. 1.04. What is the ratio of the Population (in %) in Malta in 1964 to that in 1969?
Give a very brief answer. 0.91. What is the ratio of the Population (in %) in Finland in 1964 to that in 1970?
Provide a succinct answer. 0.97. What is the ratio of the Population (in %) of Libya in 1964 to that in 1970?
Your answer should be very brief. 1.05. What is the ratio of the Population (in %) in Malta in 1964 to that in 1970?
Offer a very short reply. 0.9. What is the ratio of the Population (in %) in OECD members in 1965 to that in 1966?
Your answer should be compact. 1. What is the ratio of the Population (in %) in Finland in 1965 to that in 1966?
Ensure brevity in your answer.  0.99. What is the ratio of the Population (in %) in Libya in 1965 to that in 1966?
Offer a very short reply. 1.01. What is the ratio of the Population (in %) of Malta in 1965 to that in 1966?
Ensure brevity in your answer.  0.98. What is the ratio of the Population (in %) of Libya in 1965 to that in 1967?
Give a very brief answer. 1.02. What is the ratio of the Population (in %) of Malta in 1965 to that in 1967?
Ensure brevity in your answer.  0.96. What is the ratio of the Population (in %) in Finland in 1965 to that in 1968?
Give a very brief answer. 0.99. What is the ratio of the Population (in %) in Malta in 1965 to that in 1968?
Ensure brevity in your answer.  0.95. What is the ratio of the Population (in %) in Finland in 1965 to that in 1969?
Your answer should be very brief. 0.98. What is the ratio of the Population (in %) of Libya in 1965 to that in 1969?
Keep it short and to the point. 1.03. What is the ratio of the Population (in %) of Malta in 1965 to that in 1969?
Your answer should be compact. 0.93. What is the ratio of the Population (in %) in OECD members in 1965 to that in 1970?
Give a very brief answer. 1. What is the ratio of the Population (in %) in Finland in 1965 to that in 1970?
Provide a succinct answer. 0.98. What is the ratio of the Population (in %) of Libya in 1965 to that in 1970?
Your answer should be very brief. 1.04. What is the ratio of the Population (in %) of Malta in 1965 to that in 1970?
Your answer should be very brief. 0.92. What is the ratio of the Population (in %) of Finland in 1966 to that in 1967?
Give a very brief answer. 1. What is the ratio of the Population (in %) of Libya in 1966 to that in 1967?
Keep it short and to the point. 1.01. What is the ratio of the Population (in %) in Malta in 1966 to that in 1967?
Your response must be concise. 0.98. What is the ratio of the Population (in %) of Finland in 1966 to that in 1968?
Keep it short and to the point. 0.99. What is the ratio of the Population (in %) in Libya in 1966 to that in 1968?
Offer a very short reply. 1.02. What is the ratio of the Population (in %) in Malta in 1966 to that in 1968?
Provide a succinct answer. 0.97. What is the ratio of the Population (in %) of Finland in 1966 to that in 1969?
Make the answer very short. 0.99. What is the ratio of the Population (in %) of Malta in 1966 to that in 1969?
Offer a terse response. 0.95. What is the ratio of the Population (in %) in Finland in 1966 to that in 1970?
Your response must be concise. 0.98. What is the ratio of the Population (in %) of Libya in 1966 to that in 1970?
Offer a very short reply. 1.03. What is the ratio of the Population (in %) of Malta in 1966 to that in 1970?
Provide a short and direct response. 0.94. What is the ratio of the Population (in %) in OECD members in 1967 to that in 1968?
Your answer should be compact. 1. What is the ratio of the Population (in %) in Libya in 1967 to that in 1968?
Offer a very short reply. 1.01. What is the ratio of the Population (in %) in Malta in 1967 to that in 1968?
Provide a short and direct response. 0.98. What is the ratio of the Population (in %) in OECD members in 1967 to that in 1969?
Offer a very short reply. 1. What is the ratio of the Population (in %) in Finland in 1967 to that in 1969?
Your answer should be very brief. 0.99. What is the ratio of the Population (in %) in Libya in 1967 to that in 1969?
Provide a succinct answer. 1.02. What is the ratio of the Population (in %) in Malta in 1967 to that in 1969?
Keep it short and to the point. 0.97. What is the ratio of the Population (in %) in OECD members in 1967 to that in 1970?
Offer a terse response. 1. What is the ratio of the Population (in %) of Finland in 1967 to that in 1970?
Provide a succinct answer. 0.99. What is the ratio of the Population (in %) of Libya in 1967 to that in 1970?
Make the answer very short. 1.02. What is the ratio of the Population (in %) in Malta in 1967 to that in 1970?
Make the answer very short. 0.96. What is the ratio of the Population (in %) in OECD members in 1968 to that in 1969?
Your answer should be compact. 1. What is the ratio of the Population (in %) of Libya in 1968 to that in 1969?
Provide a short and direct response. 1.01. What is the ratio of the Population (in %) in Malta in 1968 to that in 1969?
Provide a succinct answer. 0.99. What is the ratio of the Population (in %) of Finland in 1968 to that in 1970?
Give a very brief answer. 0.99. What is the ratio of the Population (in %) of Libya in 1968 to that in 1970?
Offer a terse response. 1.01. What is the ratio of the Population (in %) of Malta in 1968 to that in 1970?
Your response must be concise. 0.97. What is the ratio of the Population (in %) of Finland in 1969 to that in 1970?
Offer a very short reply. 1. What is the ratio of the Population (in %) of Libya in 1969 to that in 1970?
Keep it short and to the point. 1.01. What is the difference between the highest and the second highest Population (in %) of OECD members?
Your answer should be very brief. 0.08. What is the difference between the highest and the second highest Population (in %) in Finland?
Offer a very short reply. 0.24. What is the difference between the highest and the second highest Population (in %) of Libya?
Your response must be concise. 0.32. What is the difference between the highest and the second highest Population (in %) in Malta?
Your answer should be compact. 0.77. What is the difference between the highest and the lowest Population (in %) in OECD members?
Give a very brief answer. 0.39. What is the difference between the highest and the lowest Population (in %) of Finland?
Provide a short and direct response. 2.59. What is the difference between the highest and the lowest Population (in %) of Libya?
Offer a terse response. 2.71. What is the difference between the highest and the lowest Population (in %) of Malta?
Offer a very short reply. 7.26. 